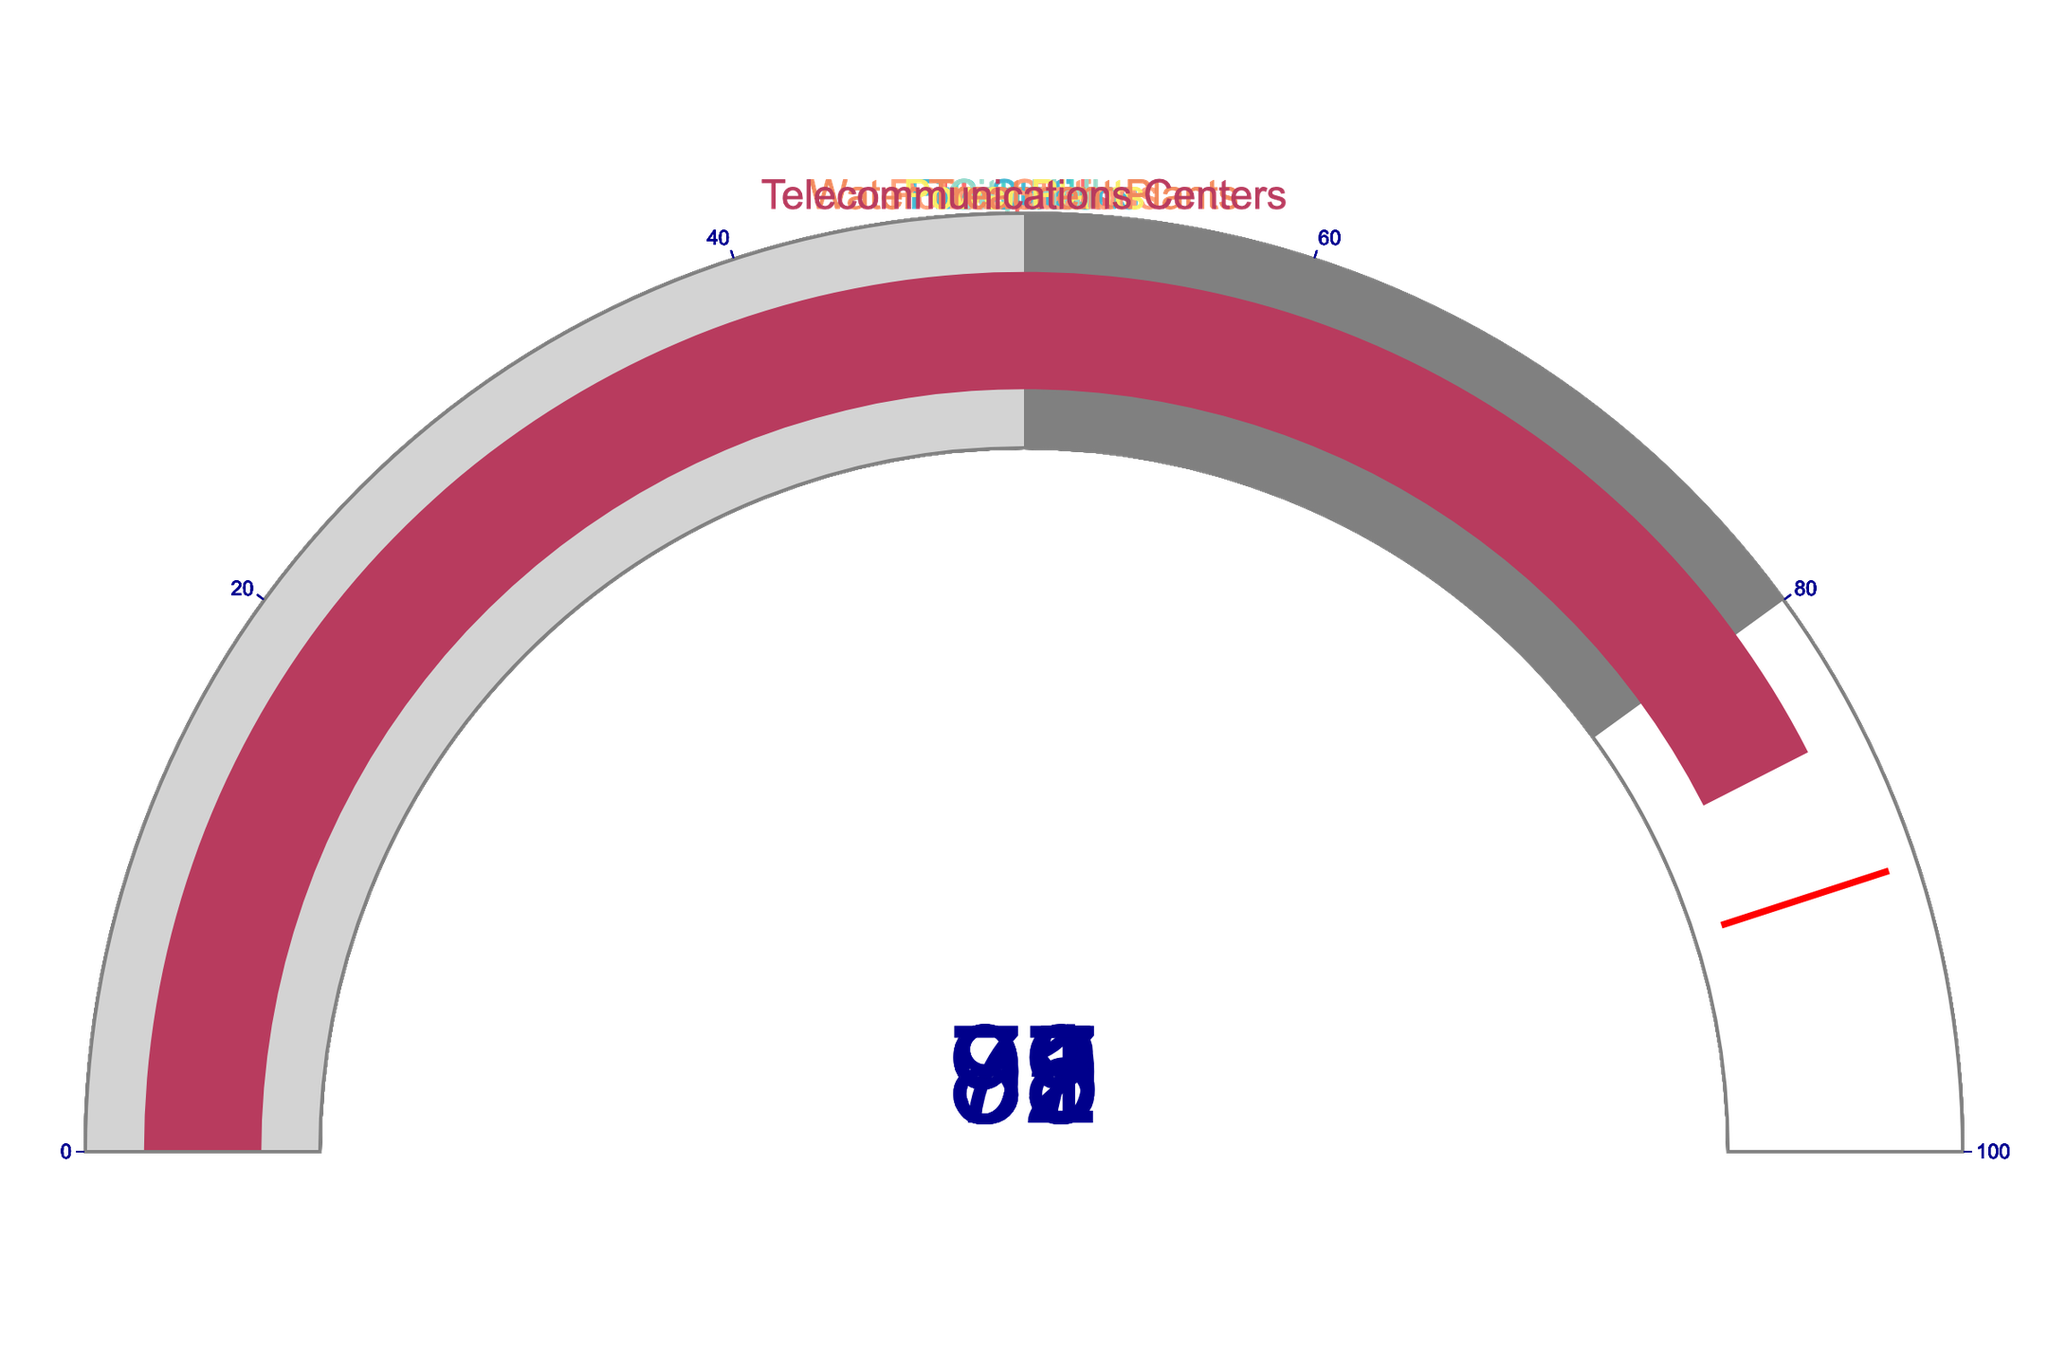what proportion of hospitals have updated disaster response plans? Look at the gauge chart labeled "Hospitals" and check the displayed value; it shows the percentage of hospitals with updated plans.
Answer: 87% What is the range of the percentage values shown in the figure? Identify the smallest and largest percentages from all the gauge charts; the smallest value is 73 (Schools), and the largest is 98 (Power Plants). The range is from 73 to 98.
Answer: 73-98 Which facility has the highest percentage of updated disaster response plans? Look at all the gauge charts and identify the one with the highest percentage value. Power Plants have the highest percentage at 98%.
Answer: Power Plants What's the average percentage across all the facilities? Sum up the percentages of all the facilities and divide by the number of facilities (87 + 73 + 92 + 89 + 95 + 98 + 91 + 85) / 8. The total is 710, and the average is 710/8.
Answer: 88.75% How many facilities have percentages of updated plans below 90%? Count the number of facilities whose gauge charts show values below 90%. These are Schools (73%), Hospitals (87%), and Telecommunications Centers (85%). There are 3 such facilities.
Answer: 3 Which facility has a percentage close to the threshold value of 90% but is below it? Find the facility whose percentage is closest to but below 90%. Telecommunications Centers have a value of 85%.
Answer: Telecommunications Centers Are there more facilities with percentages above 90% or below it? Count the number of facilities above and below 90%. There are 5 facilities above 90%: Fire Stations, Police Stations, City Hall, Power Plants, and Water Treatment Plants. There are 3 facilities below 90%: Hospitals, Schools, and Telecommunications Centers. More facilities are above 90%.
Answer: More above 90% What is the difference in the percentage of updated plans between schools and fire stations? Subtract the percentage of Schools (73%) from the percentage of Fire Stations (92%). 92 - 73 = 19.
Answer: 19 Do any facilities fall in the light gray range of 0-50% on their gauge charts? The light gray range is 0-50%, so none of the facilities fall in this range since the lowest percentage is 73% (Schools).
Answer: No Is the gauge chart for Power Plants in the threshold red line region? The red threshold line is at 90%, and Power Plants have a percentage of 98%, which is above the threshold.
Answer: Yes 